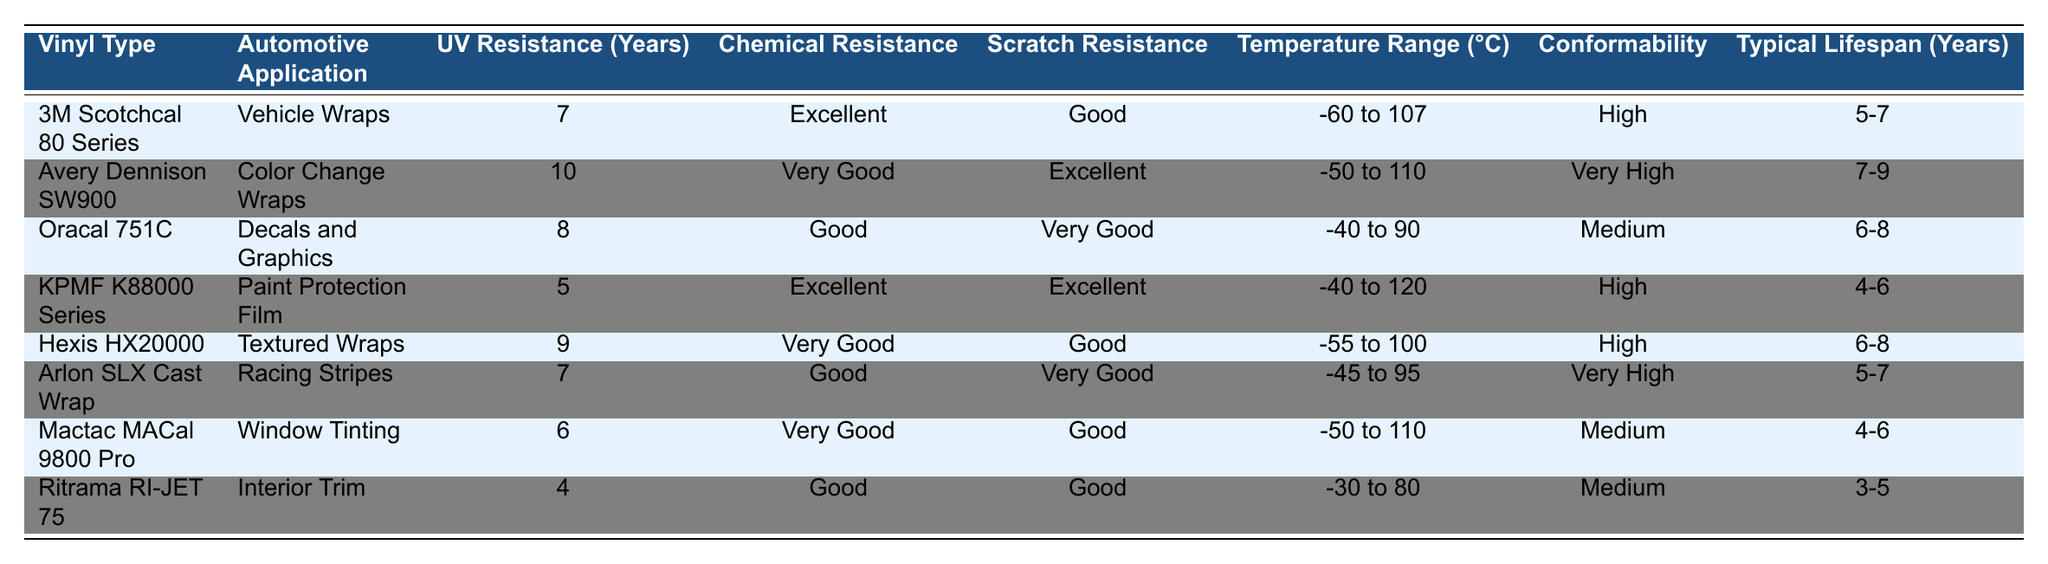What is the UV resistance of Avery Dennison SW900? The table shows that Avery Dennison SW900 has a UV resistance of 10 years.
Answer: 10 years Which vinyl type has the best chemical resistance? By comparing the chemical resistance ratings, both KPMF K88000 Series and 3M Scotchcal 80 Series have the highest rating of "Excellent".
Answer: KPMF K88000 Series and 3M Scotchcal 80 Series What is the temperature range for Hexis HX20000? The table indicates that Hexis HX20000 has a temperature range of -55 to 100 °C.
Answer: -55 to 100 °C Which automotive application uses Ritrama RI-JET 75? According to the table, Ritrama RI-JET 75 is used for Interior Trim.
Answer: Interior Trim What is the average lifespan of the vinyls listed in the table? The typical lifespans are as follows: 6, 8, 7.5, 5, 7, 6, 5, and 4 (in years). Summing these values gives 49.5. Since there are 8 vinyl types, dividing 49.5 by 8 yields an average lifespan of approximately 6.19 years.
Answer: Approximately 6.19 years Is the scratch resistance of Arlon SLX Cast Wrap classified as "Very Good"? The table shows that the scratch resistance of Arlon SLX Cast Wrap is classified as "Very Good". Hence, this statement is true.
Answer: Yes Which vinyl type has the lowest typical lifespan? Reviewing the typical lifespan values, Ritrama RI-JET 75 has the lowest range of 3-5 years.
Answer: Ritrama RI-JET 75 If I want a vinyl with excellent chemical resistance and high conformability, which option should I choose? The table lists KPMF K88000 Series as having "Excellent" chemical resistance and "High" conformability. Therefore, it is the best option for those requirements.
Answer: KPMF K88000 Series What is the difference in UV resistance between Avery Dennison SW900 and Oracal 751C? Avery Dennison SW900 has a UV resistance of 10 years, while Oracal 751C has 8 years. The difference is 10 - 8 = 2 years.
Answer: 2 years Which two vinyl types have a typical lifespan of 5-7 years? The table shows that both 3M Scotchcal 80 Series and Arlon SLX Cast Wrap have a typical lifespan of 5-7 years.
Answer: 3M Scotchcal 80 Series and Arlon SLX Cast Wrap 